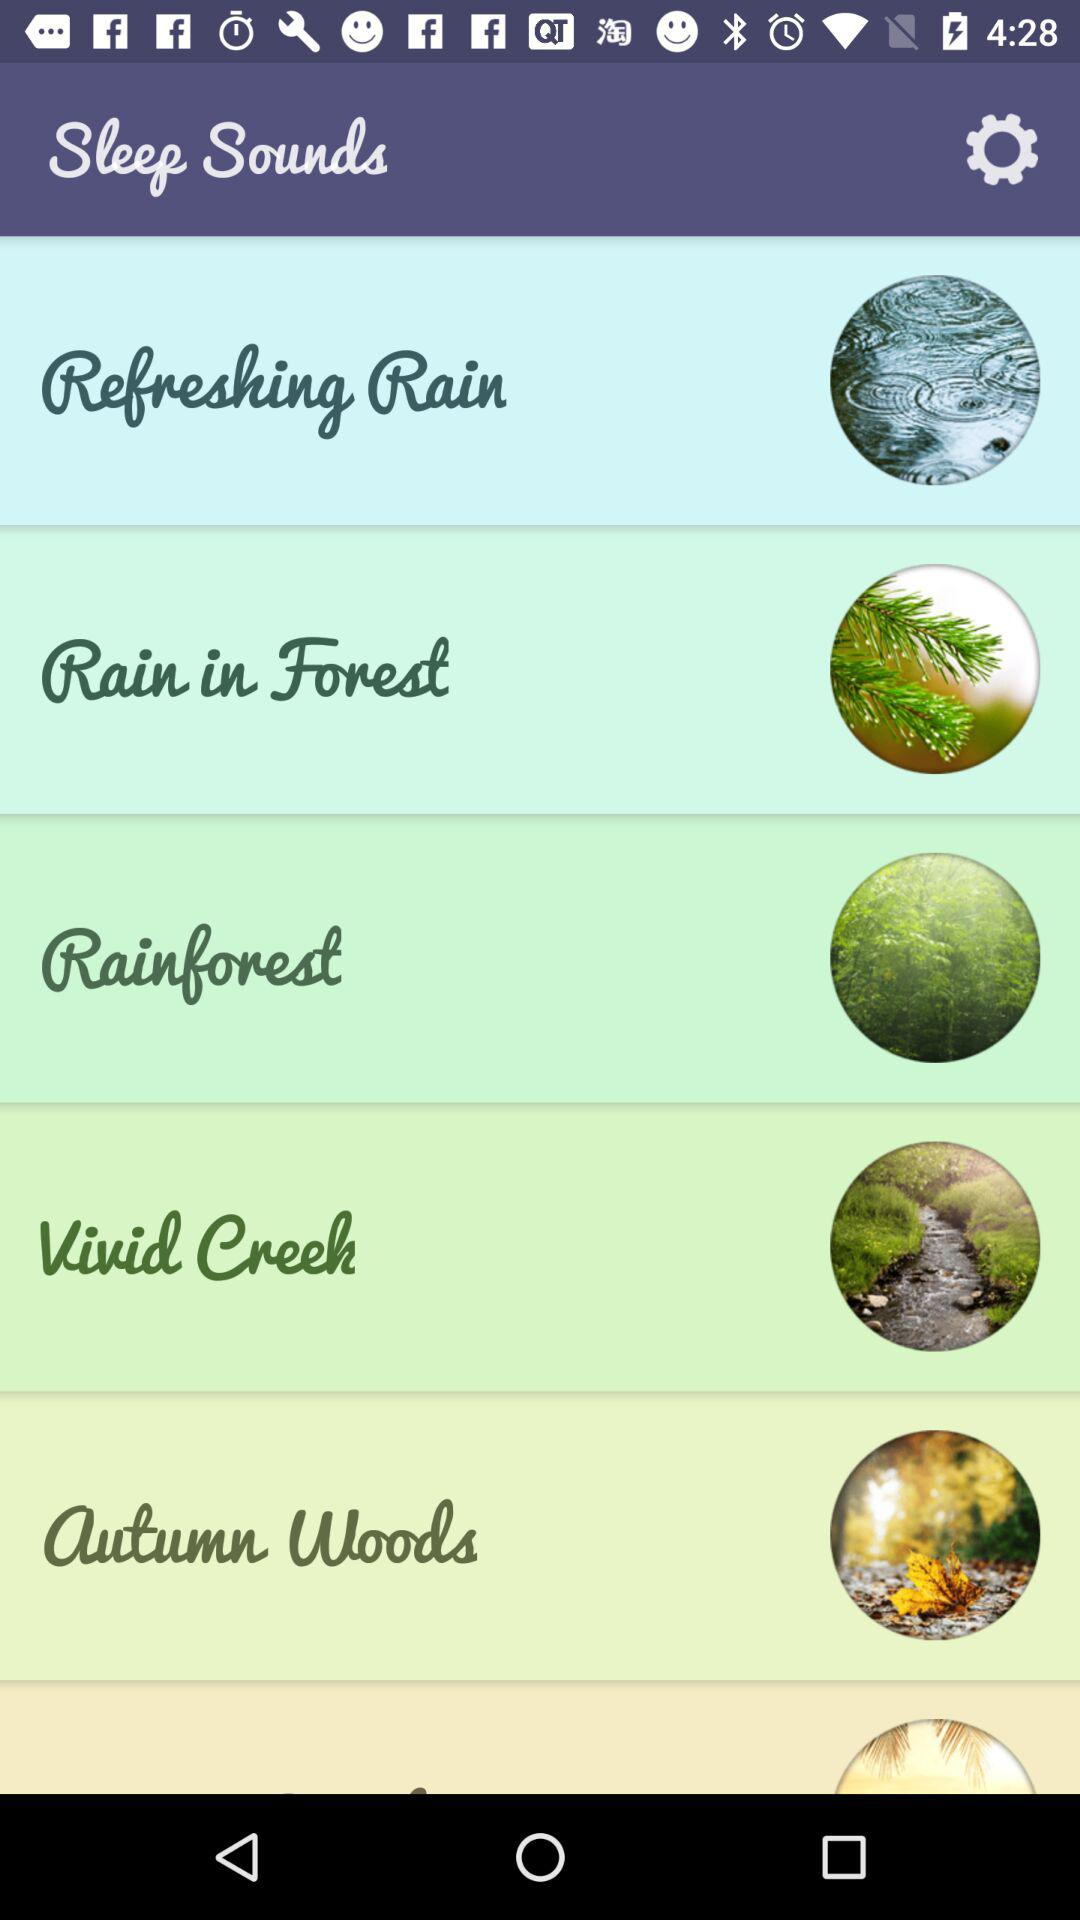What are the different types of sleep sounds? The different types of sleep sounds are "Refreshing Rain", "Rain in Forest", "Rainforest", "Vivid Creek" and "autumn woods". 